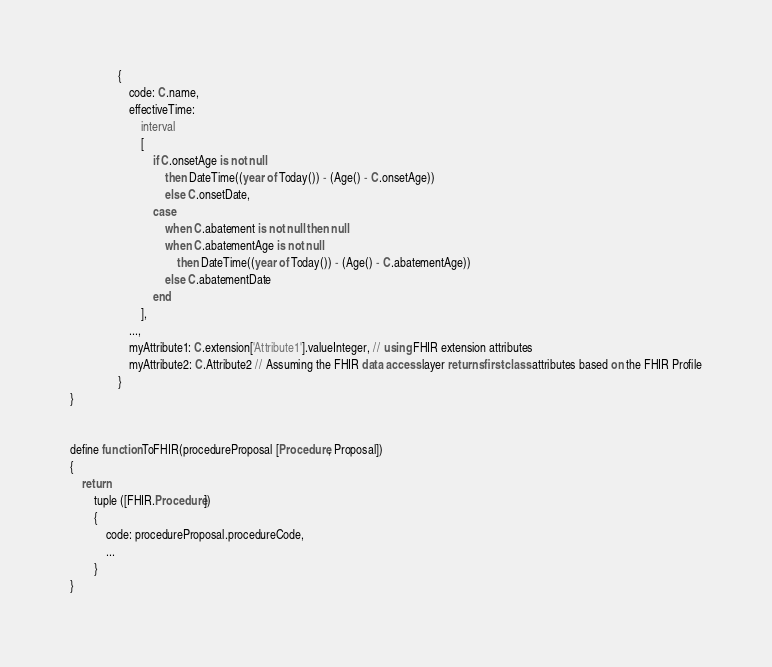Convert code to text. <code><loc_0><loc_0><loc_500><loc_500><_SQL_>				{
					code: C.name,
					effectiveTime: 
						interval
						[
							if C.onsetAge is not null 
								then DateTime((year of Today()) - (Age() - C.onsetAge))
								else C.onsetDate,
							case
								when C.abatement is not null then null
								when C.abatementAge is not null
									then DateTime((year of Today()) - (Age() - C.abatementAge))
								else C.abatementDate
							end
						],
					...,
					myAttribute1: C.extension['Attribute1'].valueInteger, // using FHIR extension attributes
					myAttribute2: C.Attribute2 // Assuming the FHIR data access layer returns first-class attributes based on the FHIR Profile
				}
}


define function ToFHIR(procedureProposal [Procedure, Proposal])
{
	return
		tuple ([FHIR.Procedure])
		{
			code: procedureProposal.procedureCode,
			...
		}
}

</code> 